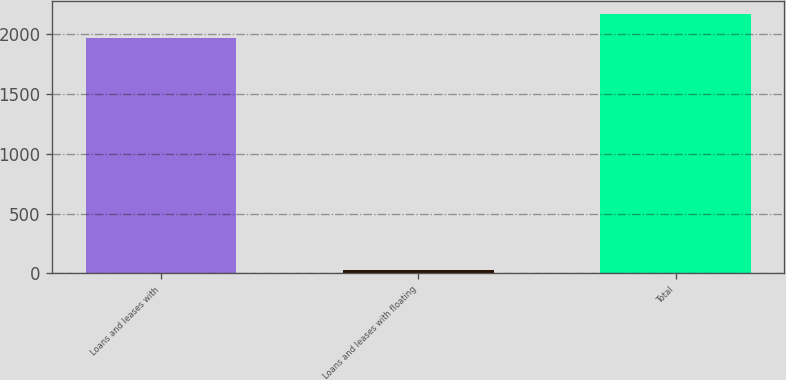Convert chart. <chart><loc_0><loc_0><loc_500><loc_500><bar_chart><fcel>Loans and leases with<fcel>Loans and leases with floating<fcel>Total<nl><fcel>1973<fcel>30<fcel>2170.3<nl></chart> 